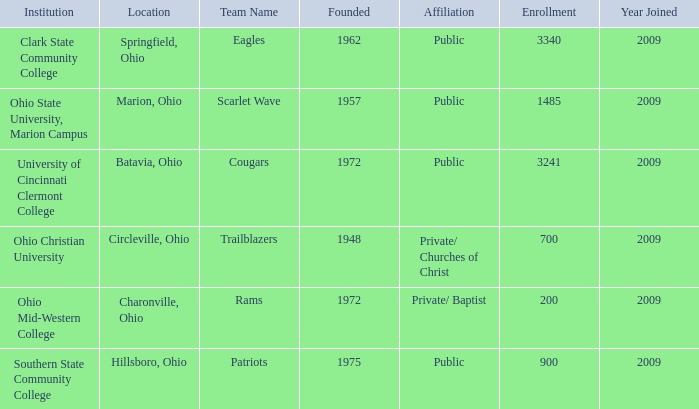How many entries are there for founded when the location was springfield, ohio? 1.0. 